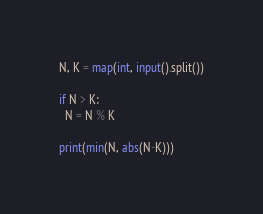Convert code to text. <code><loc_0><loc_0><loc_500><loc_500><_Python_>N, K = map(int, input().split())

if N > K:
  N = N % K

print(min(N, abs(N-K)))</code> 